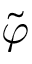Convert formula to latex. <formula><loc_0><loc_0><loc_500><loc_500>\tilde { \varphi }</formula> 